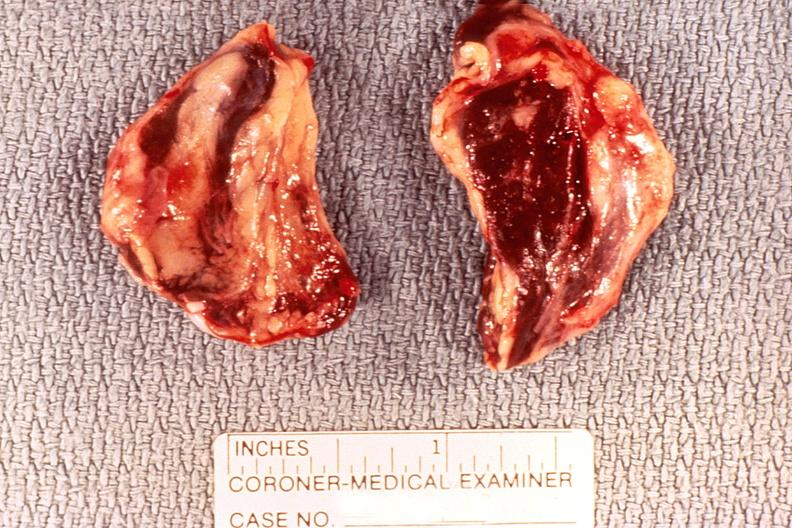does this image show adrenal gland, severe hemorrhage waterhouse-friderichsen syndrome?
Answer the question using a single word or phrase. Yes 